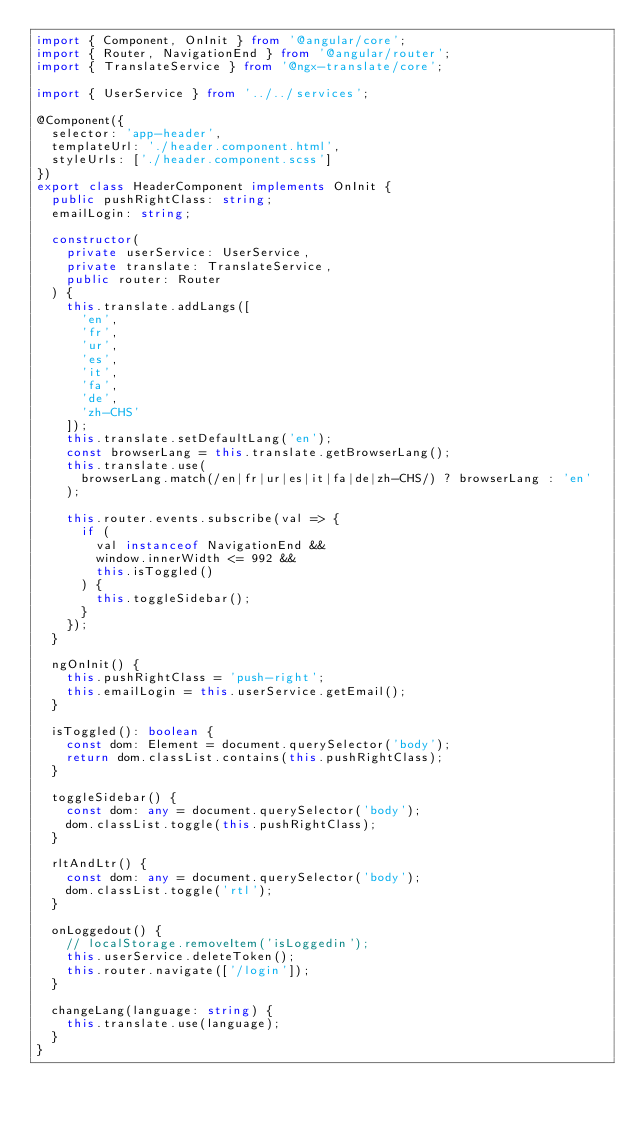<code> <loc_0><loc_0><loc_500><loc_500><_TypeScript_>import { Component, OnInit } from '@angular/core';
import { Router, NavigationEnd } from '@angular/router';
import { TranslateService } from '@ngx-translate/core';

import { UserService } from '../../services';

@Component({
  selector: 'app-header',
  templateUrl: './header.component.html',
  styleUrls: ['./header.component.scss']
})
export class HeaderComponent implements OnInit {
  public pushRightClass: string;
  emailLogin: string;

  constructor(
    private userService: UserService,
    private translate: TranslateService,
    public router: Router
  ) {
    this.translate.addLangs([
      'en',
      'fr',
      'ur',
      'es',
      'it',
      'fa',
      'de',
      'zh-CHS'
    ]);
    this.translate.setDefaultLang('en');
    const browserLang = this.translate.getBrowserLang();
    this.translate.use(
      browserLang.match(/en|fr|ur|es|it|fa|de|zh-CHS/) ? browserLang : 'en'
    );

    this.router.events.subscribe(val => {
      if (
        val instanceof NavigationEnd &&
        window.innerWidth <= 992 &&
        this.isToggled()
      ) {
        this.toggleSidebar();
      }
    });
  }

  ngOnInit() {
    this.pushRightClass = 'push-right';
    this.emailLogin = this.userService.getEmail();
  }

  isToggled(): boolean {
    const dom: Element = document.querySelector('body');
    return dom.classList.contains(this.pushRightClass);
  }

  toggleSidebar() {
    const dom: any = document.querySelector('body');
    dom.classList.toggle(this.pushRightClass);
  }

  rltAndLtr() {
    const dom: any = document.querySelector('body');
    dom.classList.toggle('rtl');
  }

  onLoggedout() {
    // localStorage.removeItem('isLoggedin');
    this.userService.deleteToken();
    this.router.navigate(['/login']);
  }

  changeLang(language: string) {
    this.translate.use(language);
  }
}
</code> 